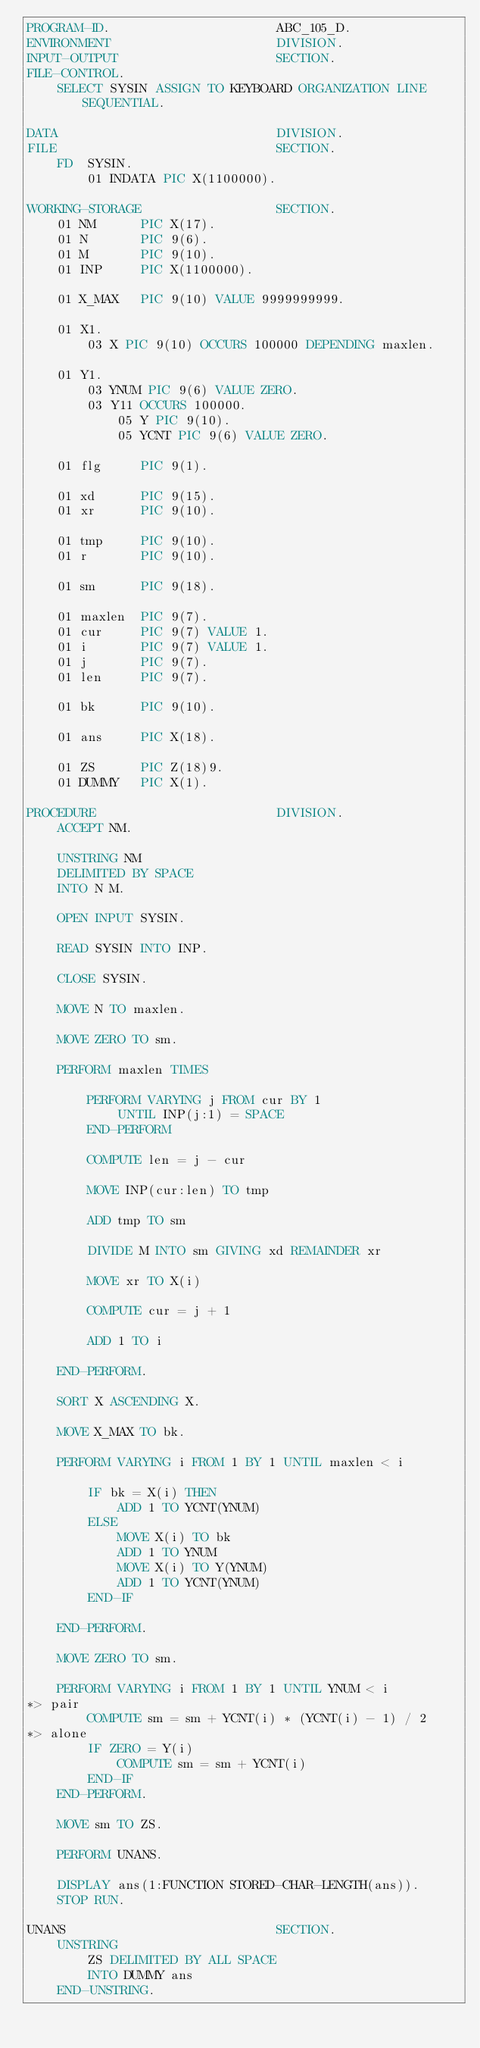Convert code to text. <code><loc_0><loc_0><loc_500><loc_500><_COBOL_>PROGRAM-ID.                      ABC_105_D.
ENVIRONMENT                      DIVISION.
INPUT-OUTPUT                     SECTION.
FILE-CONTROL.
    SELECT SYSIN ASSIGN TO KEYBOARD ORGANIZATION LINE SEQUENTIAL.

DATA                             DIVISION.
FILE                             SECTION.
    FD  SYSIN.
        01 INDATA PIC X(1100000).

WORKING-STORAGE                  SECTION.
    01 NM      PIC X(17).
    01 N       PIC 9(6).
    01 M       PIC 9(10).
    01 INP     PIC X(1100000).

    01 X_MAX   PIC 9(10) VALUE 9999999999.

    01 X1.
        03 X PIC 9(10) OCCURS 100000 DEPENDING maxlen.

    01 Y1.
        03 YNUM PIC 9(6) VALUE ZERO.
        03 Y11 OCCURS 100000.
            05 Y PIC 9(10).
            05 YCNT PIC 9(6) VALUE ZERO.

    01 flg     PIC 9(1).

    01 xd      PIC 9(15).
    01 xr      PIC 9(10).

    01 tmp     PIC 9(10).
    01 r       PIC 9(10).

    01 sm      PIC 9(18).

    01 maxlen  PIC 9(7).
    01 cur     PIC 9(7) VALUE 1.
    01 i       PIC 9(7) VALUE 1.
    01 j       PIC 9(7).
    01 len     PIC 9(7).

    01 bk      PIC 9(10).

    01 ans     PIC X(18).

    01 ZS      PIC Z(18)9.
    01 DUMMY   PIC X(1).

PROCEDURE                        DIVISION.
    ACCEPT NM.

    UNSTRING NM
    DELIMITED BY SPACE
    INTO N M.

    OPEN INPUT SYSIN.

    READ SYSIN INTO INP.

    CLOSE SYSIN.

    MOVE N TO maxlen.

    MOVE ZERO TO sm.

    PERFORM maxlen TIMES

        PERFORM VARYING j FROM cur BY 1
            UNTIL INP(j:1) = SPACE
        END-PERFORM

        COMPUTE len = j - cur

        MOVE INP(cur:len) TO tmp

        ADD tmp TO sm

        DIVIDE M INTO sm GIVING xd REMAINDER xr

        MOVE xr TO X(i)

        COMPUTE cur = j + 1

        ADD 1 TO i

    END-PERFORM.

    SORT X ASCENDING X.

    MOVE X_MAX TO bk.

    PERFORM VARYING i FROM 1 BY 1 UNTIL maxlen < i

        IF bk = X(i) THEN
            ADD 1 TO YCNT(YNUM)
        ELSE
            MOVE X(i) TO bk
            ADD 1 TO YNUM
            MOVE X(i) TO Y(YNUM)
            ADD 1 TO YCNT(YNUM)
        END-IF

    END-PERFORM.

    MOVE ZERO TO sm.

    PERFORM VARYING i FROM 1 BY 1 UNTIL YNUM < i
*> pair
        COMPUTE sm = sm + YCNT(i) * (YCNT(i) - 1) / 2
*> alone
        IF ZERO = Y(i)
            COMPUTE sm = sm + YCNT(i)
        END-IF
    END-PERFORM.

    MOVE sm TO ZS.

    PERFORM UNANS.

    DISPLAY ans(1:FUNCTION STORED-CHAR-LENGTH(ans)).
    STOP RUN.

UNANS                            SECTION.
    UNSTRING
        ZS DELIMITED BY ALL SPACE
        INTO DUMMY ans
    END-UNSTRING.
</code> 